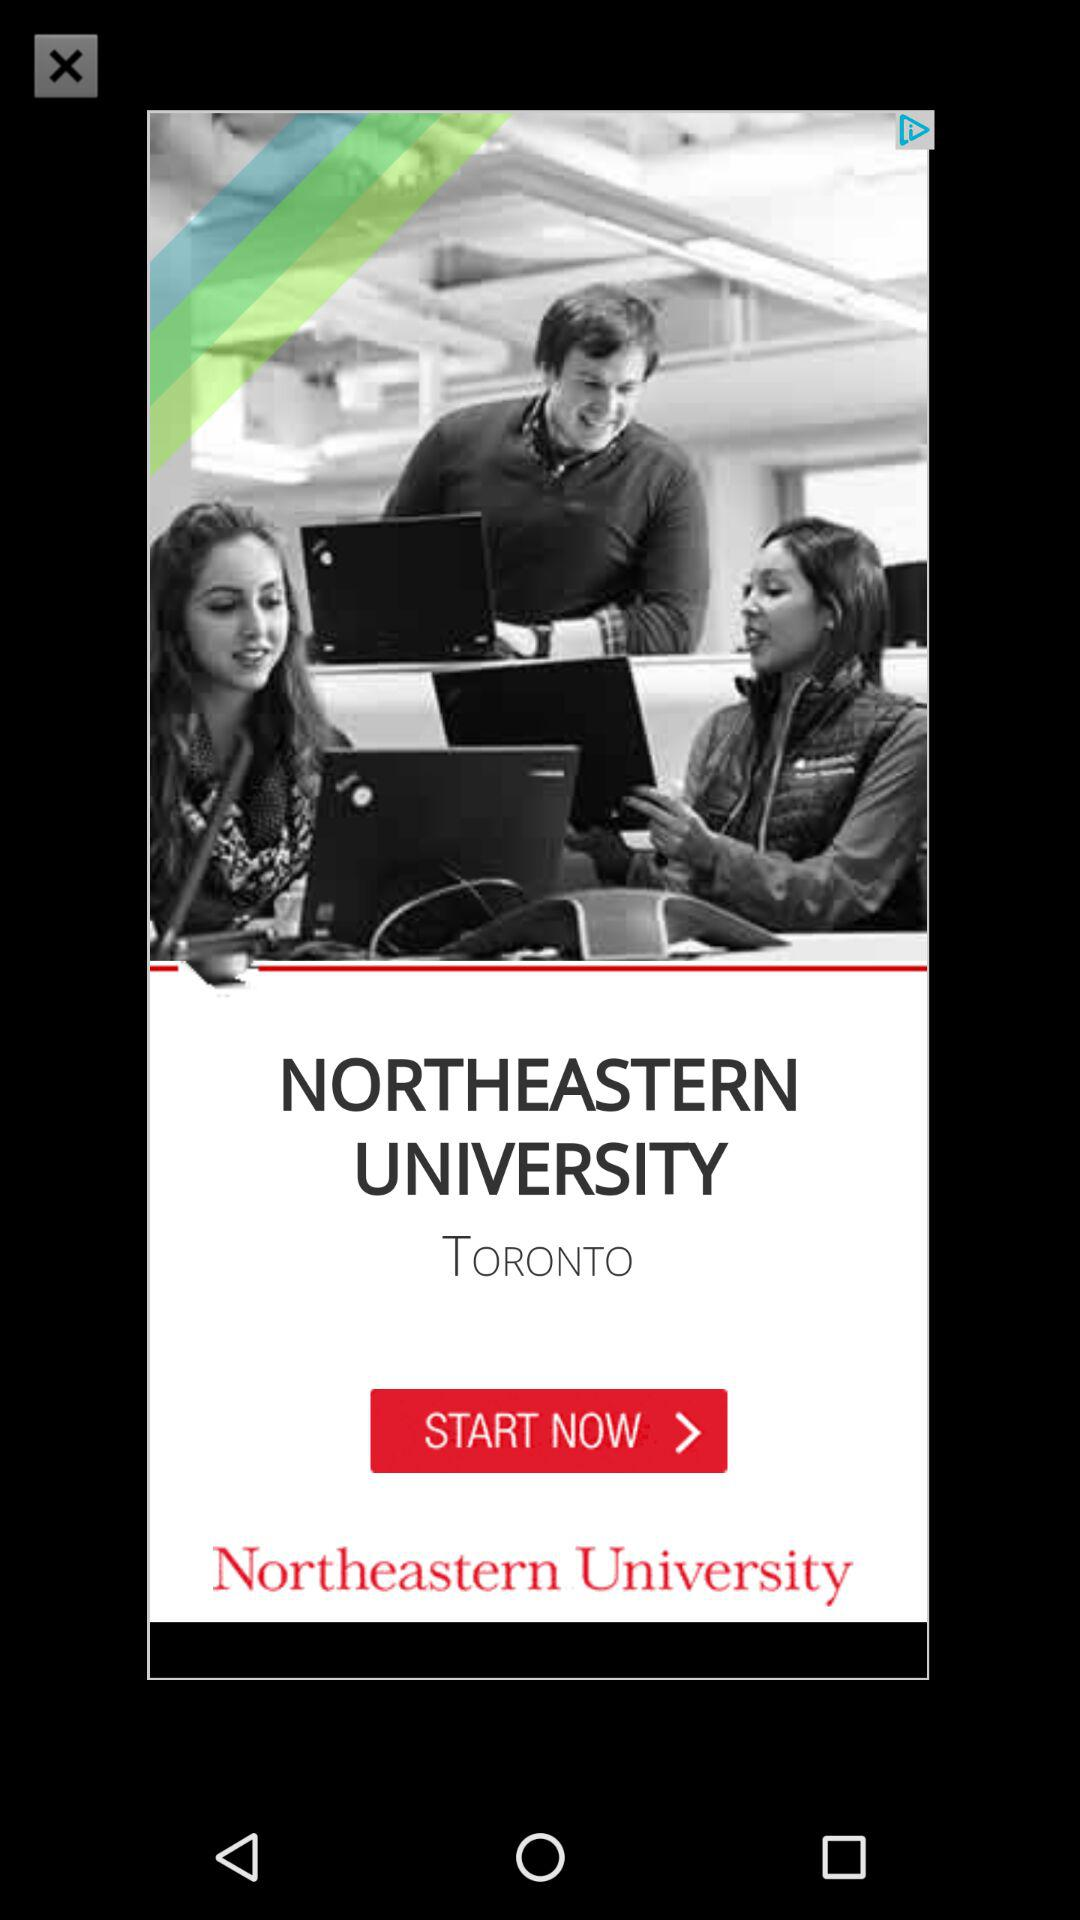Where is "Northeastern University" located? "Northeastern University" is located in Toronto. 